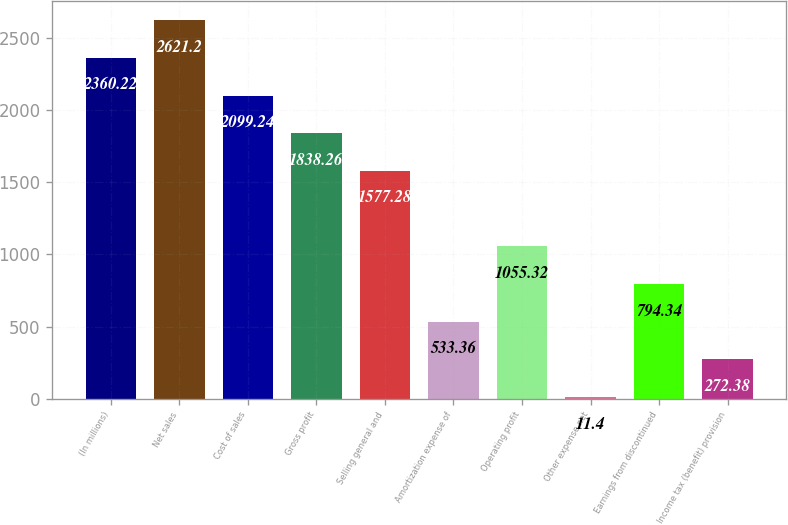<chart> <loc_0><loc_0><loc_500><loc_500><bar_chart><fcel>(In millions)<fcel>Net sales<fcel>Cost of sales<fcel>Gross profit<fcel>Selling general and<fcel>Amortization expense of<fcel>Operating profit<fcel>Other expense net<fcel>Earnings from discontinued<fcel>Income tax (benefit) provision<nl><fcel>2360.22<fcel>2621.2<fcel>2099.24<fcel>1838.26<fcel>1577.28<fcel>533.36<fcel>1055.32<fcel>11.4<fcel>794.34<fcel>272.38<nl></chart> 